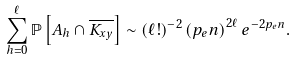Convert formula to latex. <formula><loc_0><loc_0><loc_500><loc_500>\sum _ { h = 0 } ^ { \ell } \mathbb { P } \left [ A _ { h } \cap \overline { K _ { { x } { y } } } \right ] & \sim ( { \ell } ! ) ^ { - 2 } \left ( { p _ { e } } n \right ) ^ { 2 \ell } e ^ { - 2 { p _ { e } } n } .</formula> 